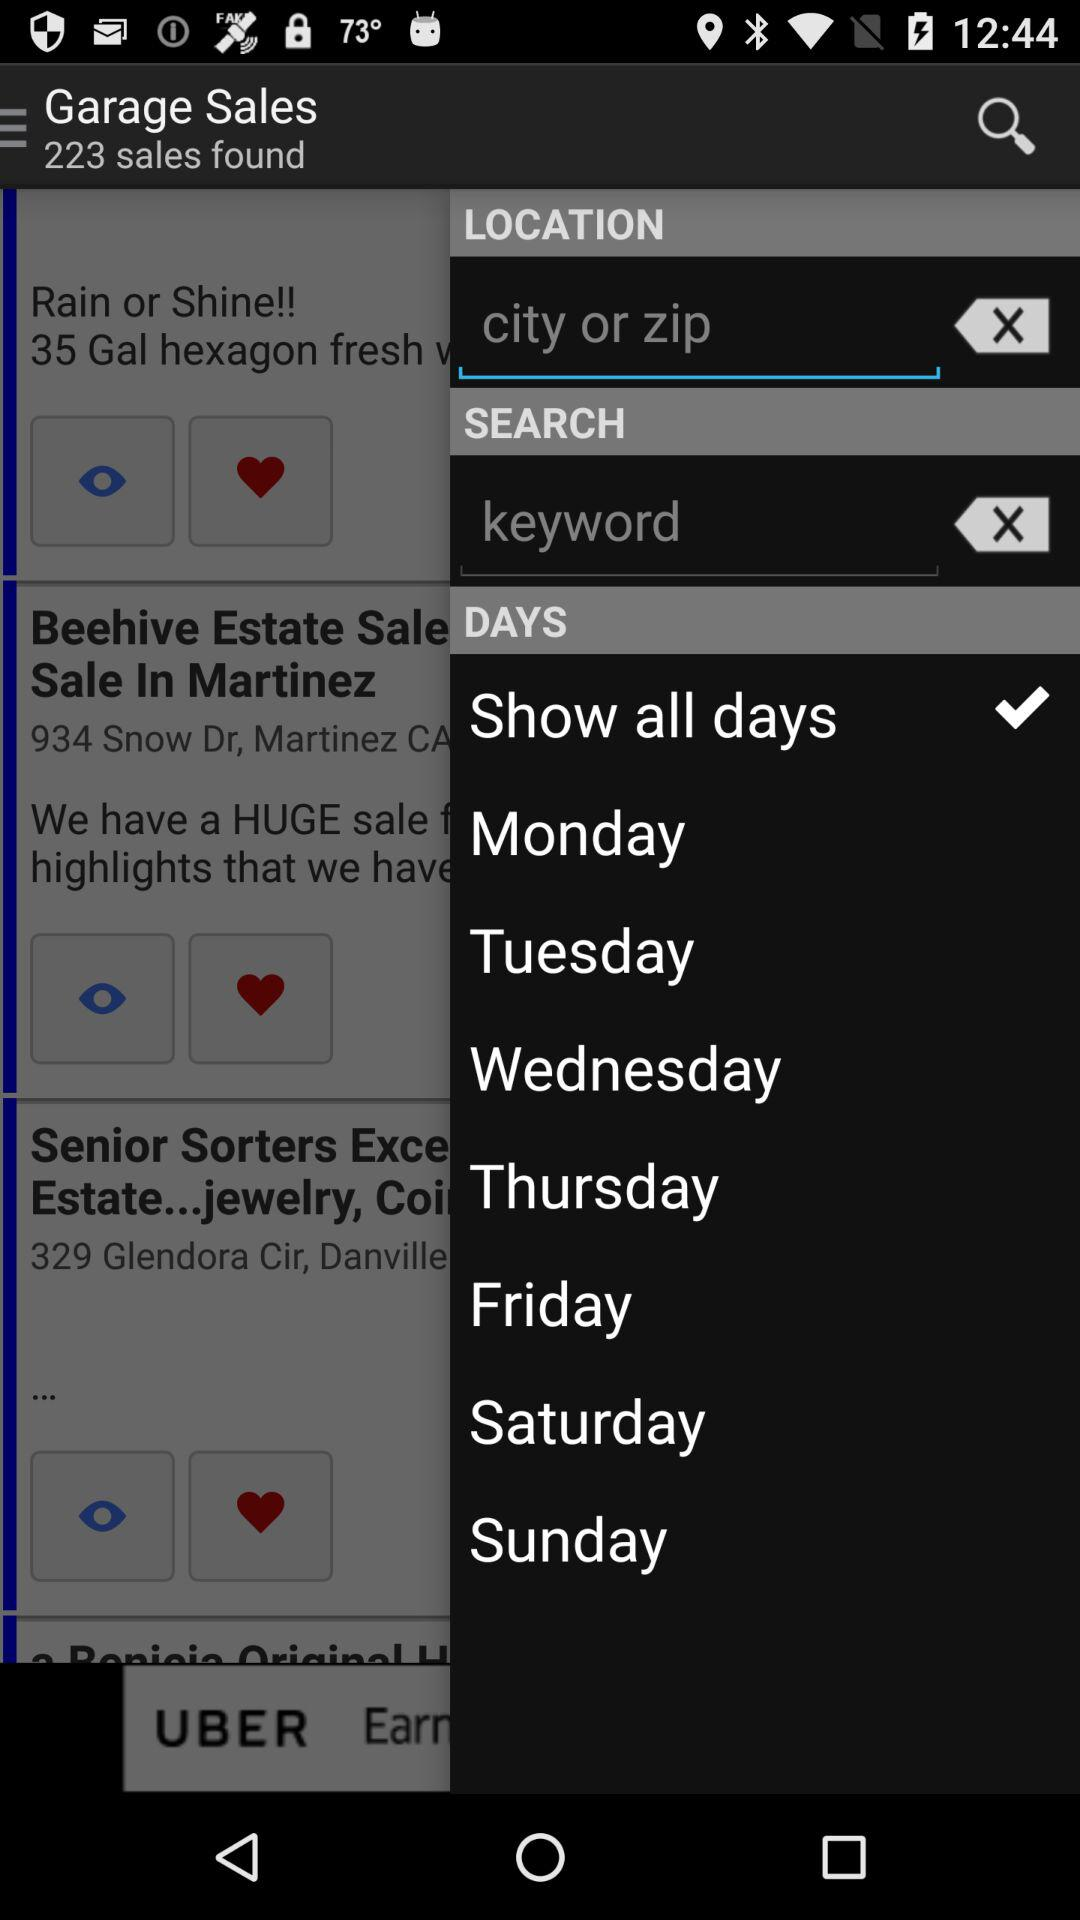How many sales are found in "Garage Sales"? There are 223 sales found in "Garage Sales". 